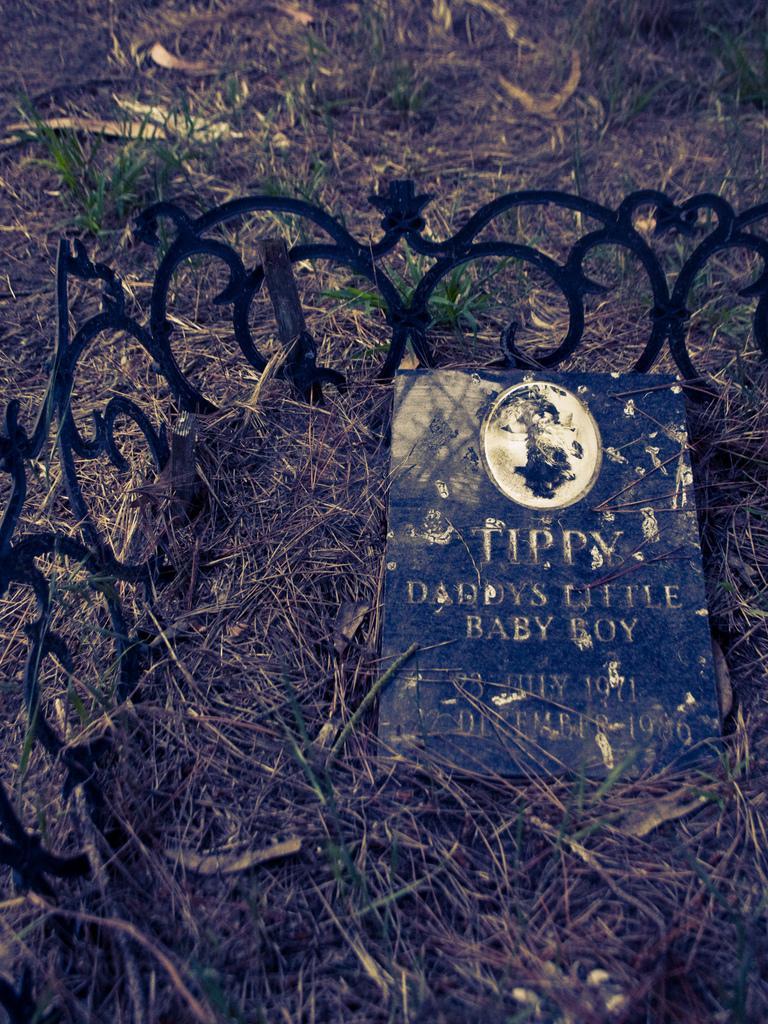How would you summarize this image in a sentence or two? At the bottom of the image on the ground there is grass. And also there is a an object with text on it. Behind that there is a fencing with design. 